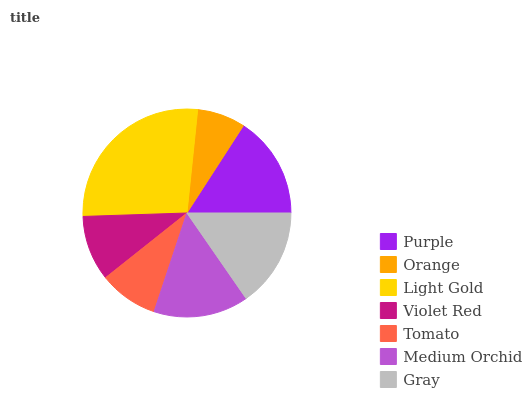Is Orange the minimum?
Answer yes or no. Yes. Is Light Gold the maximum?
Answer yes or no. Yes. Is Light Gold the minimum?
Answer yes or no. No. Is Orange the maximum?
Answer yes or no. No. Is Light Gold greater than Orange?
Answer yes or no. Yes. Is Orange less than Light Gold?
Answer yes or no. Yes. Is Orange greater than Light Gold?
Answer yes or no. No. Is Light Gold less than Orange?
Answer yes or no. No. Is Medium Orchid the high median?
Answer yes or no. Yes. Is Medium Orchid the low median?
Answer yes or no. Yes. Is Orange the high median?
Answer yes or no. No. Is Tomato the low median?
Answer yes or no. No. 